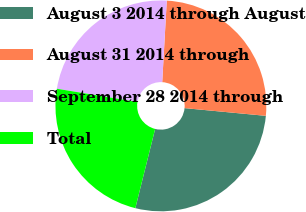<chart> <loc_0><loc_0><loc_500><loc_500><pie_chart><fcel>August 3 2014 through August<fcel>August 31 2014 through<fcel>September 28 2014 through<fcel>Total<nl><fcel>27.39%<fcel>25.62%<fcel>23.29%<fcel>23.7%<nl></chart> 